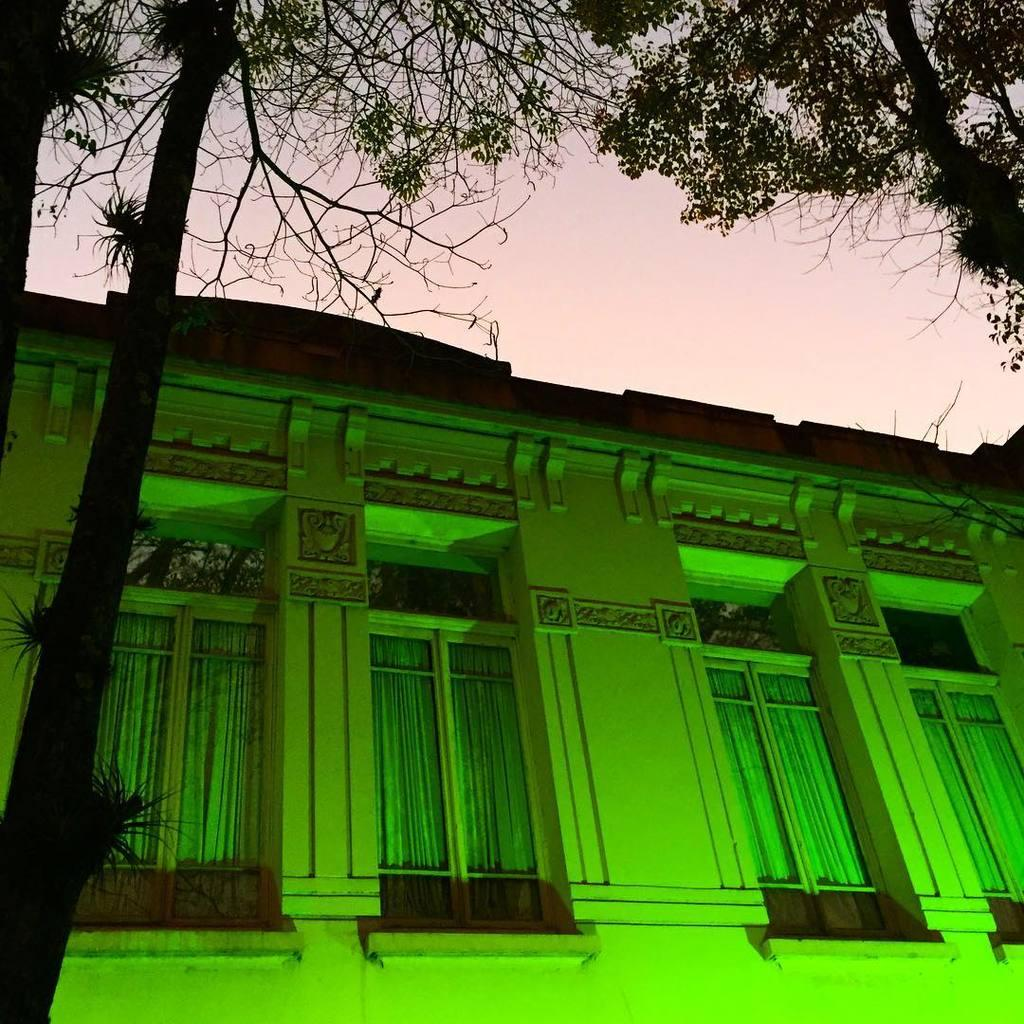What type of structure is present in the image? There is a building in the image. What other natural element can be seen in the image? There is a tree in the image. What is visible in the background of the image? The sky is visible in the image. What feature can be observed on the building? The building has windows. Who is the creator of the lunch depicted in the image? There is no lunch depicted in the image, so there is no creator to identify. What type of weather condition is present in the image? The provided facts do not mention any specific weather conditions, so we cannot determine if there is fog or any other weather condition in the image. 